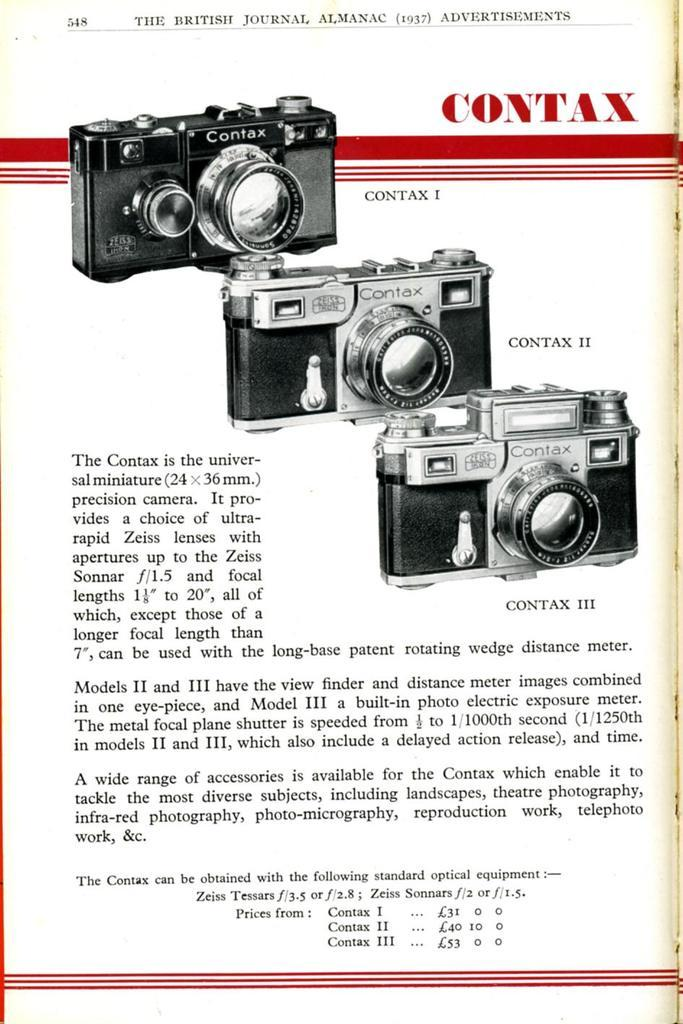<image>
Give a short and clear explanation of the subsequent image. an advertisement for the contax camera, frayed at the right edge 